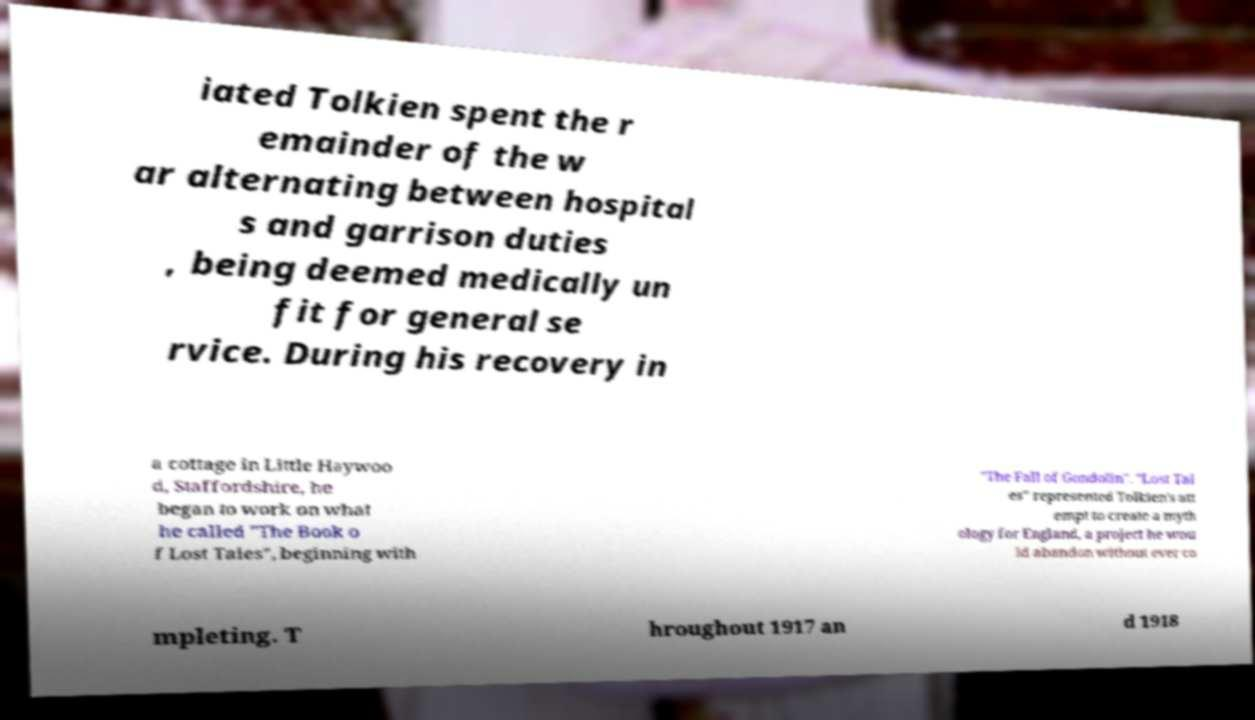There's text embedded in this image that I need extracted. Can you transcribe it verbatim? iated Tolkien spent the r emainder of the w ar alternating between hospital s and garrison duties , being deemed medically un fit for general se rvice. During his recovery in a cottage in Little Haywoo d, Staffordshire, he began to work on what he called "The Book o f Lost Tales", beginning with "The Fall of Gondolin". "Lost Tal es" represented Tolkien's att empt to create a myth ology for England, a project he wou ld abandon without ever co mpleting. T hroughout 1917 an d 1918 